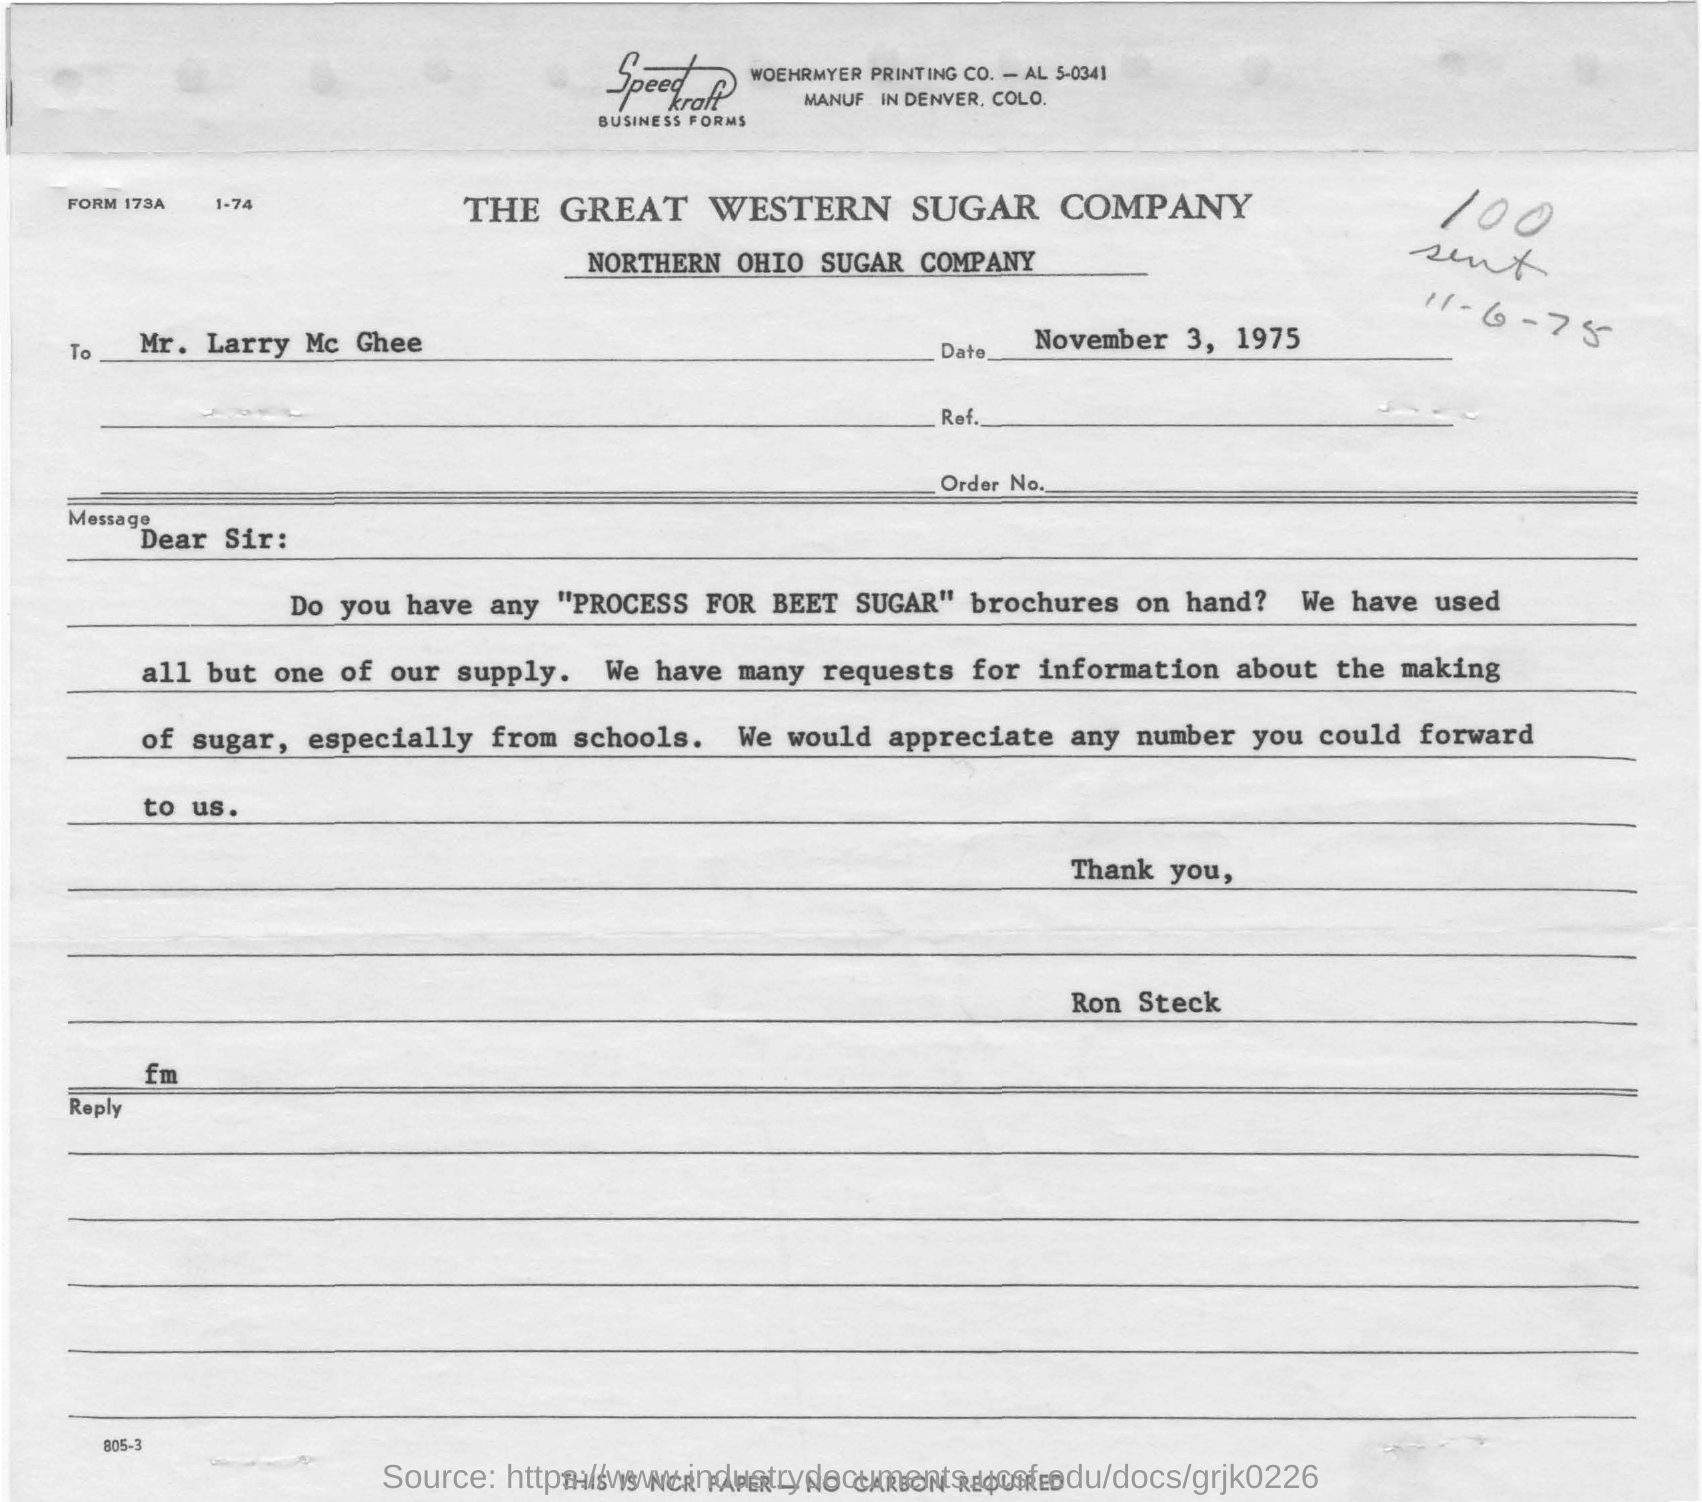Given the date on the letter, how might the processes described in the 'PROCESS FOR BEET SUGAR' brochure have changed up until now? Since the letter dates back to 1975, the beet sugar production process might have undergone significant changes due to advancements in agricultural techniques, sustainability practices, and production technologies. Modern brochures would likely include information on the use of automation, improvements in energy efficiency, and perhaps the implementation of more eco-friendly practices. 